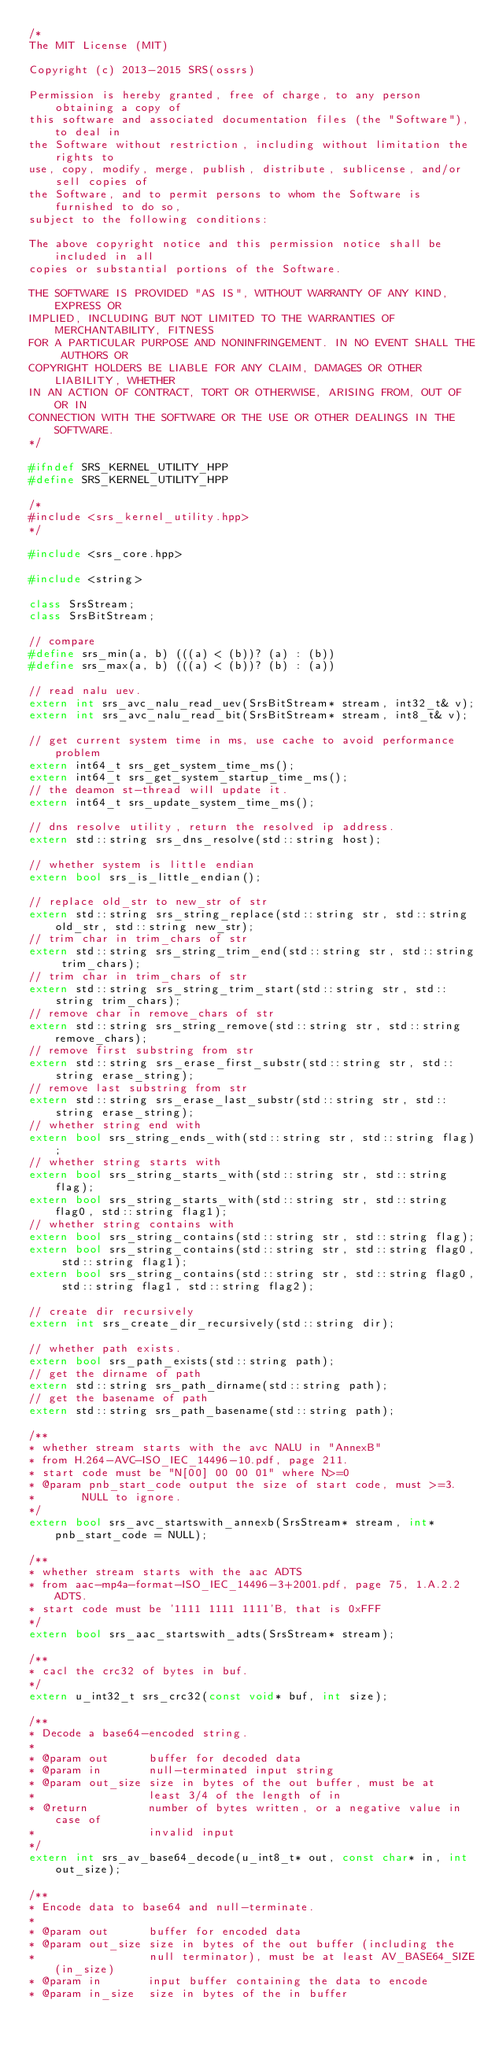Convert code to text. <code><loc_0><loc_0><loc_500><loc_500><_C++_>/*
The MIT License (MIT)

Copyright (c) 2013-2015 SRS(ossrs)

Permission is hereby granted, free of charge, to any person obtaining a copy of
this software and associated documentation files (the "Software"), to deal in
the Software without restriction, including without limitation the rights to
use, copy, modify, merge, publish, distribute, sublicense, and/or sell copies of
the Software, and to permit persons to whom the Software is furnished to do so,
subject to the following conditions:

The above copyright notice and this permission notice shall be included in all
copies or substantial portions of the Software.

THE SOFTWARE IS PROVIDED "AS IS", WITHOUT WARRANTY OF ANY KIND, EXPRESS OR
IMPLIED, INCLUDING BUT NOT LIMITED TO THE WARRANTIES OF MERCHANTABILITY, FITNESS
FOR A PARTICULAR PURPOSE AND NONINFRINGEMENT. IN NO EVENT SHALL THE AUTHORS OR
COPYRIGHT HOLDERS BE LIABLE FOR ANY CLAIM, DAMAGES OR OTHER LIABILITY, WHETHER
IN AN ACTION OF CONTRACT, TORT OR OTHERWISE, ARISING FROM, OUT OF OR IN
CONNECTION WITH THE SOFTWARE OR THE USE OR OTHER DEALINGS IN THE SOFTWARE.
*/

#ifndef SRS_KERNEL_UTILITY_HPP
#define SRS_KERNEL_UTILITY_HPP

/*
#include <srs_kernel_utility.hpp>
*/

#include <srs_core.hpp>

#include <string>

class SrsStream;
class SrsBitStream;

// compare
#define srs_min(a, b) (((a) < (b))? (a) : (b))
#define srs_max(a, b) (((a) < (b))? (b) : (a))

// read nalu uev.
extern int srs_avc_nalu_read_uev(SrsBitStream* stream, int32_t& v);
extern int srs_avc_nalu_read_bit(SrsBitStream* stream, int8_t& v);

// get current system time in ms, use cache to avoid performance problem
extern int64_t srs_get_system_time_ms();
extern int64_t srs_get_system_startup_time_ms();
// the deamon st-thread will update it.
extern int64_t srs_update_system_time_ms();

// dns resolve utility, return the resolved ip address.
extern std::string srs_dns_resolve(std::string host);

// whether system is little endian
extern bool srs_is_little_endian();

// replace old_str to new_str of str
extern std::string srs_string_replace(std::string str, std::string old_str, std::string new_str);
// trim char in trim_chars of str
extern std::string srs_string_trim_end(std::string str, std::string trim_chars);
// trim char in trim_chars of str
extern std::string srs_string_trim_start(std::string str, std::string trim_chars);
// remove char in remove_chars of str
extern std::string srs_string_remove(std::string str, std::string remove_chars);
// remove first substring from str
extern std::string srs_erase_first_substr(std::string str, std::string erase_string);
// remove last substring from str
extern std::string srs_erase_last_substr(std::string str, std::string erase_string);
// whether string end with
extern bool srs_string_ends_with(std::string str, std::string flag);
// whether string starts with
extern bool srs_string_starts_with(std::string str, std::string flag);
extern bool srs_string_starts_with(std::string str, std::string flag0, std::string flag1);
// whether string contains with
extern bool srs_string_contains(std::string str, std::string flag);
extern bool srs_string_contains(std::string str, std::string flag0, std::string flag1);
extern bool srs_string_contains(std::string str, std::string flag0, std::string flag1, std::string flag2);

// create dir recursively
extern int srs_create_dir_recursively(std::string dir);

// whether path exists.
extern bool srs_path_exists(std::string path);
// get the dirname of path
extern std::string srs_path_dirname(std::string path);
// get the basename of path
extern std::string srs_path_basename(std::string path);

/**
* whether stream starts with the avc NALU in "AnnexB" 
* from H.264-AVC-ISO_IEC_14496-10.pdf, page 211.
* start code must be "N[00] 00 00 01" where N>=0
* @param pnb_start_code output the size of start code, must >=3. 
*       NULL to ignore.
*/
extern bool srs_avc_startswith_annexb(SrsStream* stream, int* pnb_start_code = NULL);

/**
* whether stream starts with the aac ADTS 
* from aac-mp4a-format-ISO_IEC_14496-3+2001.pdf, page 75, 1.A.2.2 ADTS.
* start code must be '1111 1111 1111'B, that is 0xFFF
*/
extern bool srs_aac_startswith_adts(SrsStream* stream);

/**
* cacl the crc32 of bytes in buf.
*/
extern u_int32_t srs_crc32(const void* buf, int size);

/**
* Decode a base64-encoded string.
*
* @param out      buffer for decoded data
* @param in       null-terminated input string
* @param out_size size in bytes of the out buffer, must be at
*                 least 3/4 of the length of in
* @return         number of bytes written, or a negative value in case of
*                 invalid input
*/
extern int srs_av_base64_decode(u_int8_t* out, const char* in, int out_size);

/**
* Encode data to base64 and null-terminate.
*
* @param out      buffer for encoded data
* @param out_size size in bytes of the out buffer (including the
*                 null terminator), must be at least AV_BASE64_SIZE(in_size)
* @param in       input buffer containing the data to encode
* @param in_size  size in bytes of the in buffer</code> 